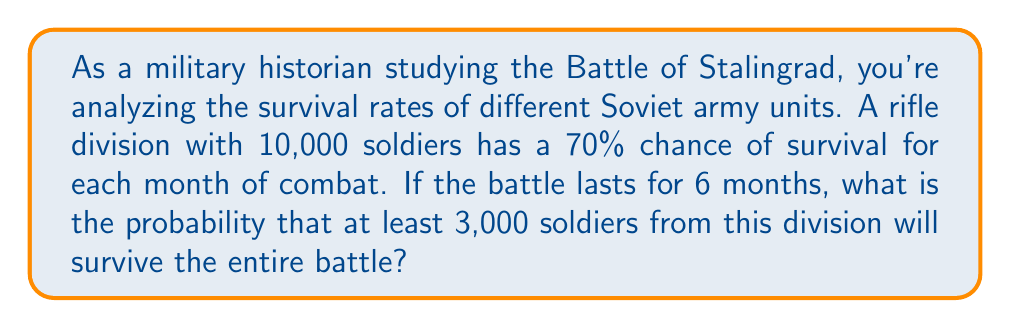Teach me how to tackle this problem. To solve this problem, we'll use the binomial probability distribution and the complement rule.

1) First, let's calculate the probability of a single soldier surviving the entire 6-month battle:
   $P(\text{survival}) = 0.7^6 \approx 0.1176$

2) Now, we need to find the probability that at least 3,000 soldiers survive. It's easier to calculate the probability of fewer than 3,000 surviving and then subtract from 1.

3) We can use the binomial cumulative distribution function:

   $$P(X < 3000) = \sum_{k=0}^{2999} \binom{10000}{k} (0.1176)^k (1-0.1176)^{10000-k}$$

4) This calculation is complex, so we'll use the normal approximation to the binomial distribution:

   Mean: $\mu = np = 10000 * 0.1176 = 1176$
   Standard deviation: $\sigma = \sqrt{np(1-p)} = \sqrt{10000 * 0.1176 * 0.8824} \approx 32.27$

5) We need to find $P(X < 3000)$, which in z-score terms is:

   $z = \frac{2999.5 - 1176}{32.27} \approx 56.51$

6) The probability of $z > 56.51$ is essentially 1.

7) Therefore, $P(X \geq 3000) = 1 - P(X < 3000) \approx 1 - 1 = 0$
Answer: The probability that at least 3,000 soldiers will survive the entire 6-month battle is approximately 0. 